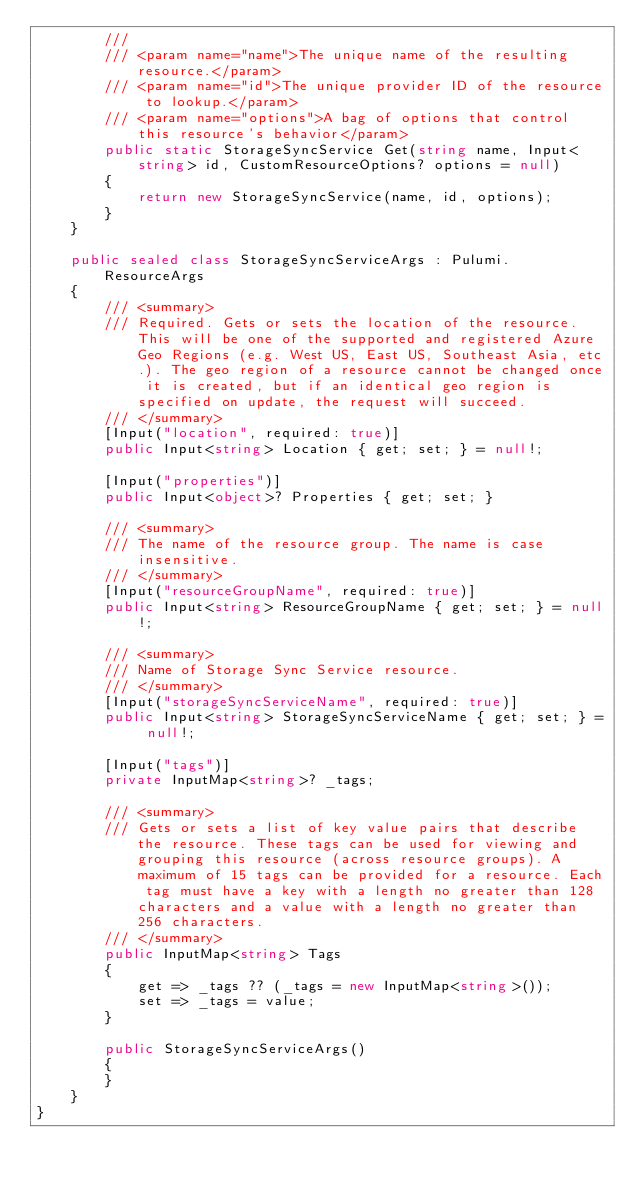Convert code to text. <code><loc_0><loc_0><loc_500><loc_500><_C#_>        ///
        /// <param name="name">The unique name of the resulting resource.</param>
        /// <param name="id">The unique provider ID of the resource to lookup.</param>
        /// <param name="options">A bag of options that control this resource's behavior</param>
        public static StorageSyncService Get(string name, Input<string> id, CustomResourceOptions? options = null)
        {
            return new StorageSyncService(name, id, options);
        }
    }

    public sealed class StorageSyncServiceArgs : Pulumi.ResourceArgs
    {
        /// <summary>
        /// Required. Gets or sets the location of the resource. This will be one of the supported and registered Azure Geo Regions (e.g. West US, East US, Southeast Asia, etc.). The geo region of a resource cannot be changed once it is created, but if an identical geo region is specified on update, the request will succeed.
        /// </summary>
        [Input("location", required: true)]
        public Input<string> Location { get; set; } = null!;

        [Input("properties")]
        public Input<object>? Properties { get; set; }

        /// <summary>
        /// The name of the resource group. The name is case insensitive.
        /// </summary>
        [Input("resourceGroupName", required: true)]
        public Input<string> ResourceGroupName { get; set; } = null!;

        /// <summary>
        /// Name of Storage Sync Service resource.
        /// </summary>
        [Input("storageSyncServiceName", required: true)]
        public Input<string> StorageSyncServiceName { get; set; } = null!;

        [Input("tags")]
        private InputMap<string>? _tags;

        /// <summary>
        /// Gets or sets a list of key value pairs that describe the resource. These tags can be used for viewing and grouping this resource (across resource groups). A maximum of 15 tags can be provided for a resource. Each tag must have a key with a length no greater than 128 characters and a value with a length no greater than 256 characters.
        /// </summary>
        public InputMap<string> Tags
        {
            get => _tags ?? (_tags = new InputMap<string>());
            set => _tags = value;
        }

        public StorageSyncServiceArgs()
        {
        }
    }
}
</code> 